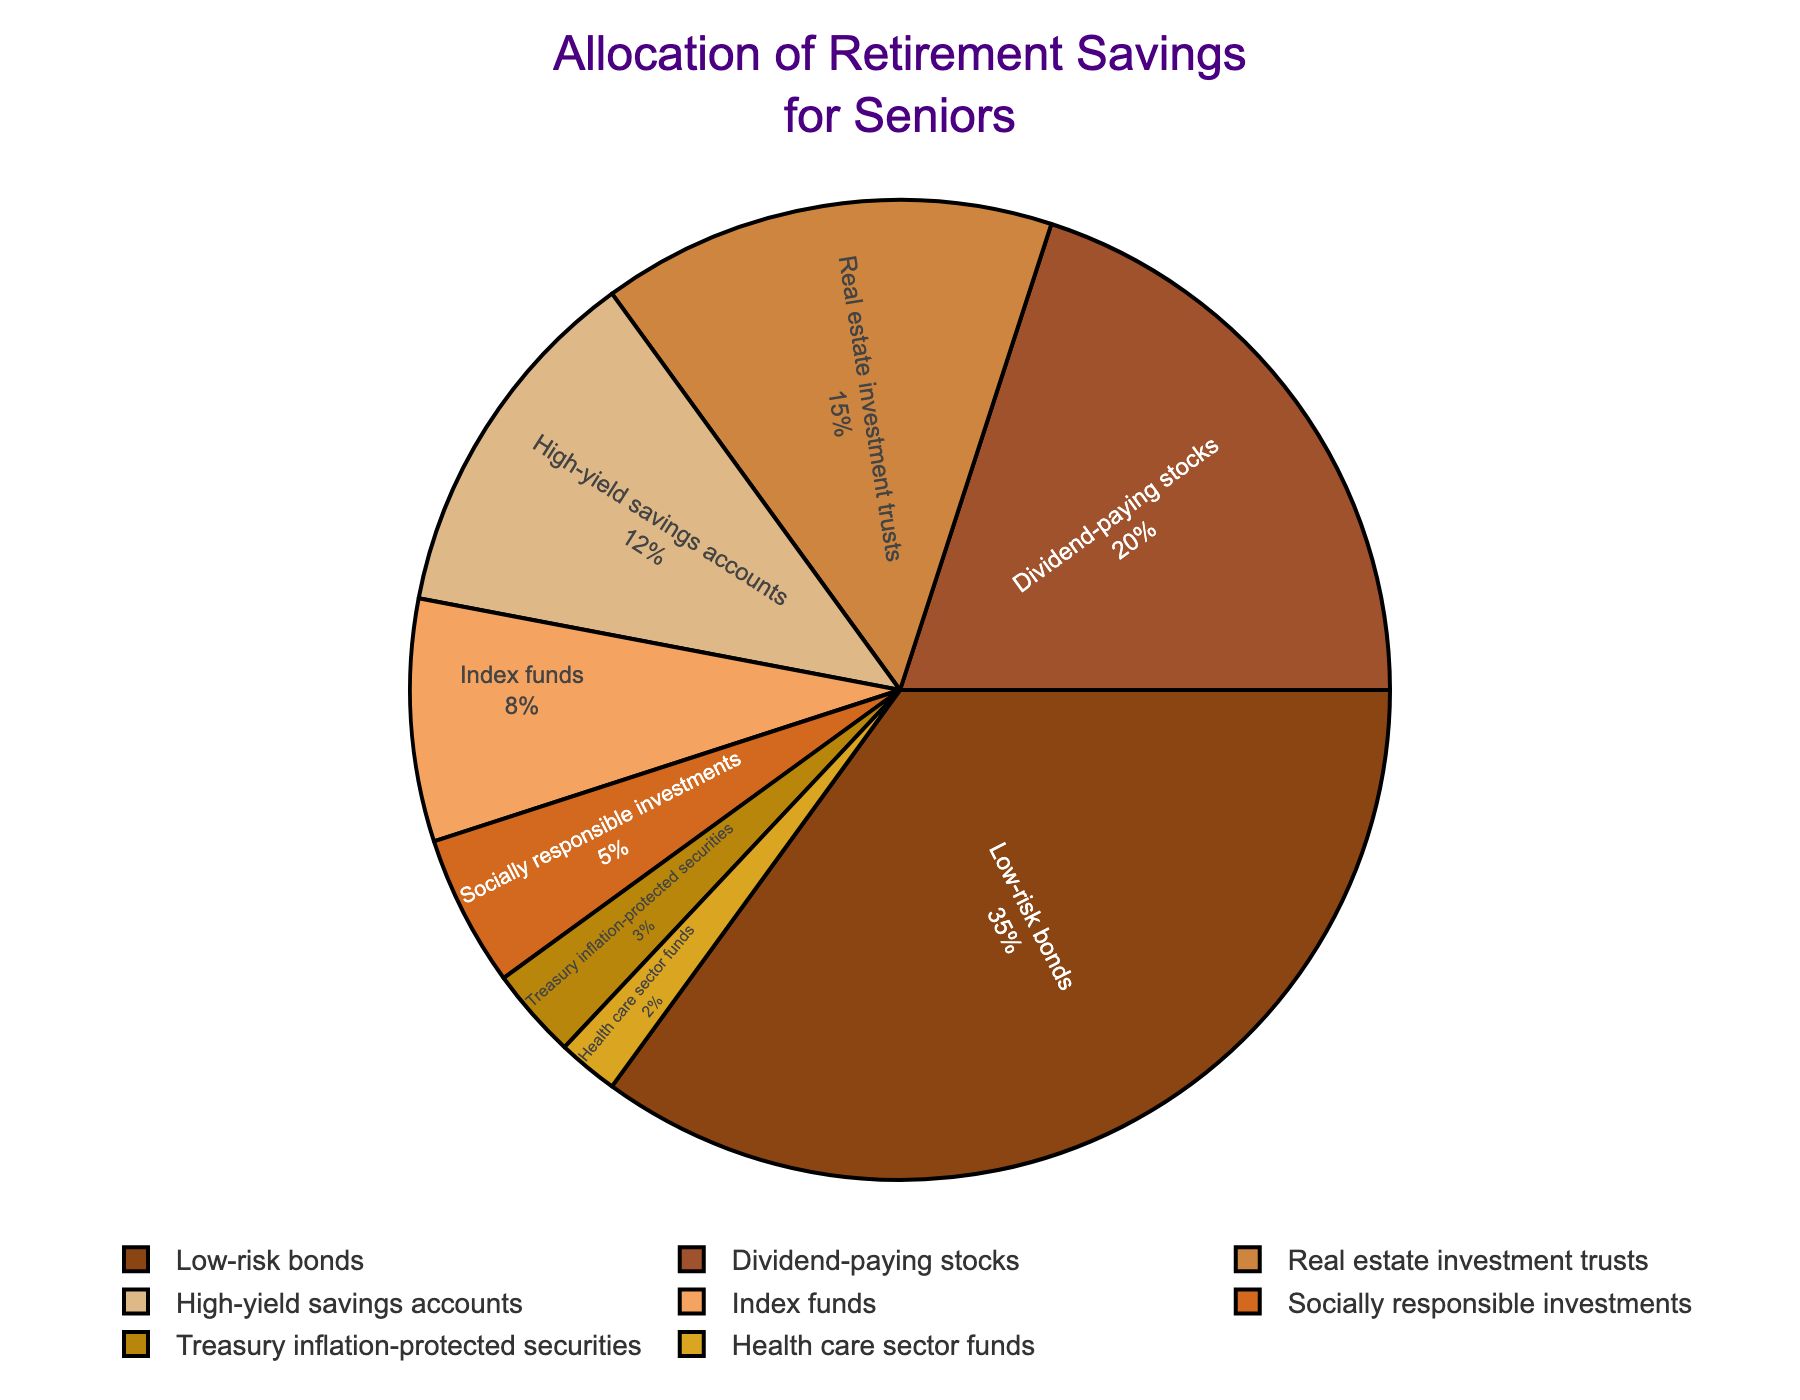What percentage of retirement savings is allocated to low-risk bonds? Look at the pie chart and find the segment labeled "Low-risk bonds." The percentage shown is 35%.
Answer: 35% How much more is allocated to dividend-paying stocks compared to index funds? Find the percentage for dividend-paying stocks (20%) and index funds (8%). Subtract the latter from the former: 20% - 8% = 12%.
Answer: 12% What is the combined percentage of investments in high-yield savings accounts and socially responsible investments? Find the percentage for high-yield savings accounts (12%) and socially responsible investments (5%). Add them together: 12% + 5% = 17%.
Answer: 17% Which investment type has the smallest allocation, and what is its percentage? Look at the pie chart and identify the smallest segment. It is labeled "Health care sector funds" with a percentage of 2%.
Answer: Health care sector funds, 2% Compare the allocation for real estate investment trusts and treasury inflation-protected securities. Which one has a higher allocation, and by how much? Look at the percentages for real estate investment trusts (15%) and treasury inflation-protected securities (3%). Subtract the smaller from the larger: 15% - 3% = 12%.
Answer: Real estate investment trusts, 12% What is the sum of the percentages for the three investment types with the smallest allocations? Identify the three smallest percentages: Health care sector funds (2%), treasury inflation-protected securities (3%), and socially responsible investments (5%). Add them together: 2% + 3% + 5% = 10%.
Answer: 10% Which segment in the pie chart is represented with the darkest color, and what is its associated investment type? The darkest color is used for "Low-risk bonds." Look at the color legend to verify.
Answer: Low-risk bonds What percentage of the total investments is allocated to areas related to stocks (both dividend-paying stocks and index funds)? Find the percentages for dividend-paying stocks (20%) and index funds (8%). Add them together: 20% + 8% = 28%.
Answer: 28% How does the allocation for high-yield savings accounts compare to treasury inflation-protected securities? Look at the percentages for high-yield savings accounts (12%) and treasury inflation-protected securities (3%). The former is greater: 12% - 3% = 9%.
Answer: High-yield savings accounts, 9% If an extra 5% were to be allocated to socially responsible investments by reducing the allocation for low-risk bonds, what would the new percentages be for both investment types? Current percentage for socially responsible investments is 5%. Add 5% to get 10%. Current percentage for low-risk bonds is 35%. Subtract 5% to get 30%.
Answer: Socially responsible investments: 10%, Low-risk bonds: 30% 